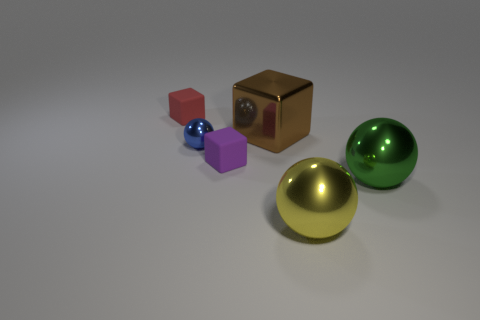This image seems to be computer-generated. Could you discuss the lighting and shadows evident in the scene? Certainly. This computer-generated image utilizes soft lighting to create subtle shadows that ground the objects, providing a natural sense of depth. The shadows are soft-edged, which indicates a diffused light source – much like an overcast day. The lighting is positioned to enhance the three-dimensionality of the shapes, while the matte and reflective surfaces react differently to the light, showcasing their unique textures. 